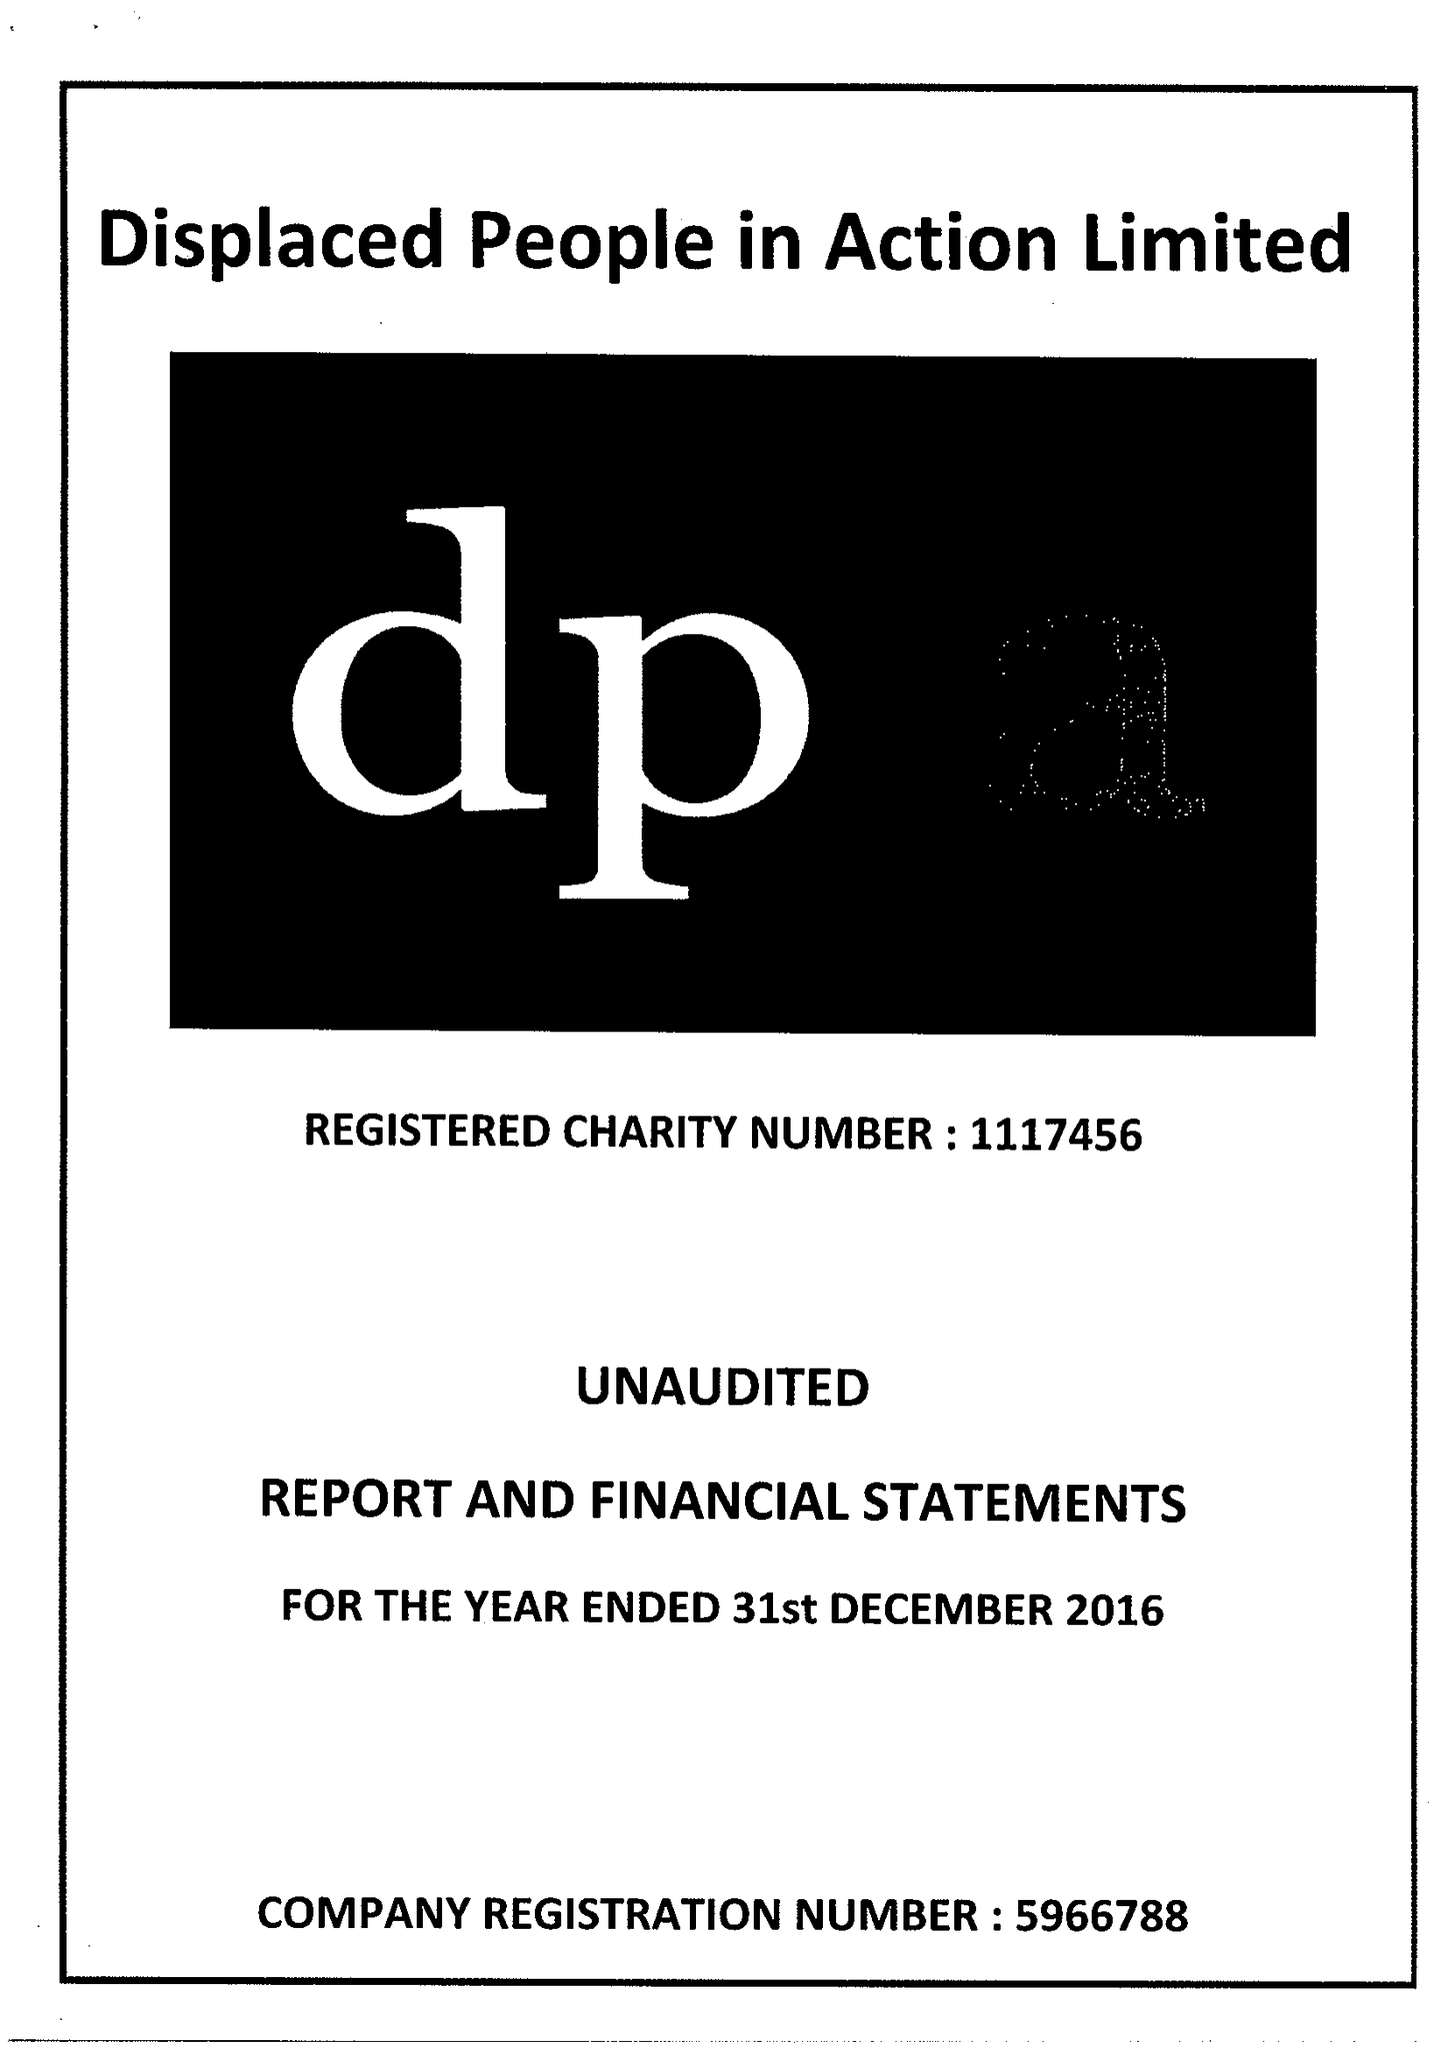What is the value for the spending_annually_in_british_pounds?
Answer the question using a single word or phrase. 408060.00 